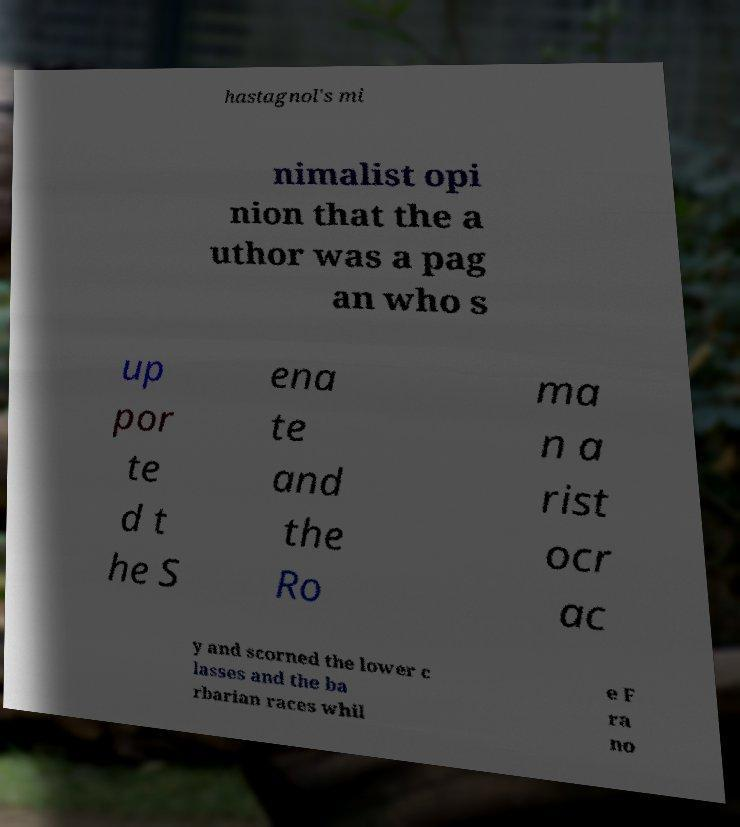Can you read and provide the text displayed in the image?This photo seems to have some interesting text. Can you extract and type it out for me? hastagnol's mi nimalist opi nion that the a uthor was a pag an who s up por te d t he S ena te and the Ro ma n a rist ocr ac y and scorned the lower c lasses and the ba rbarian races whil e F ra no 